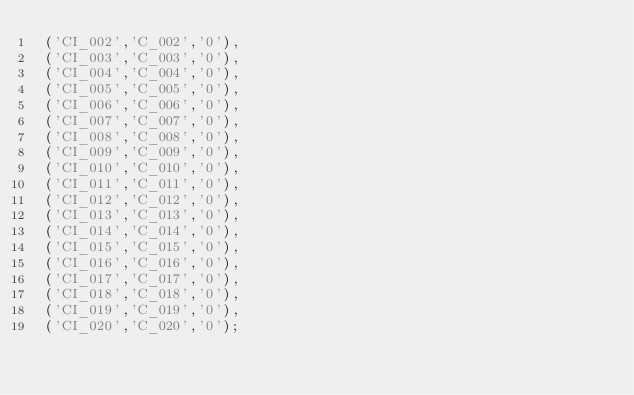Convert code to text. <code><loc_0><loc_0><loc_500><loc_500><_SQL_> ('CI_002','C_002','0'),
 ('CI_003','C_003','0'),
 ('CI_004','C_004','0'),
 ('CI_005','C_005','0'),
 ('CI_006','C_006','0'),
 ('CI_007','C_007','0'),
 ('CI_008','C_008','0'),
 ('CI_009','C_009','0'),
 ('CI_010','C_010','0'),
 ('CI_011','C_011','0'),
 ('CI_012','C_012','0'),
 ('CI_013','C_013','0'),
 ('CI_014','C_014','0'),
 ('CI_015','C_015','0'),
 ('CI_016','C_016','0'),
 ('CI_017','C_017','0'),
 ('CI_018','C_018','0'),
 ('CI_019','C_019','0'),
 ('CI_020','C_020','0');

</code> 